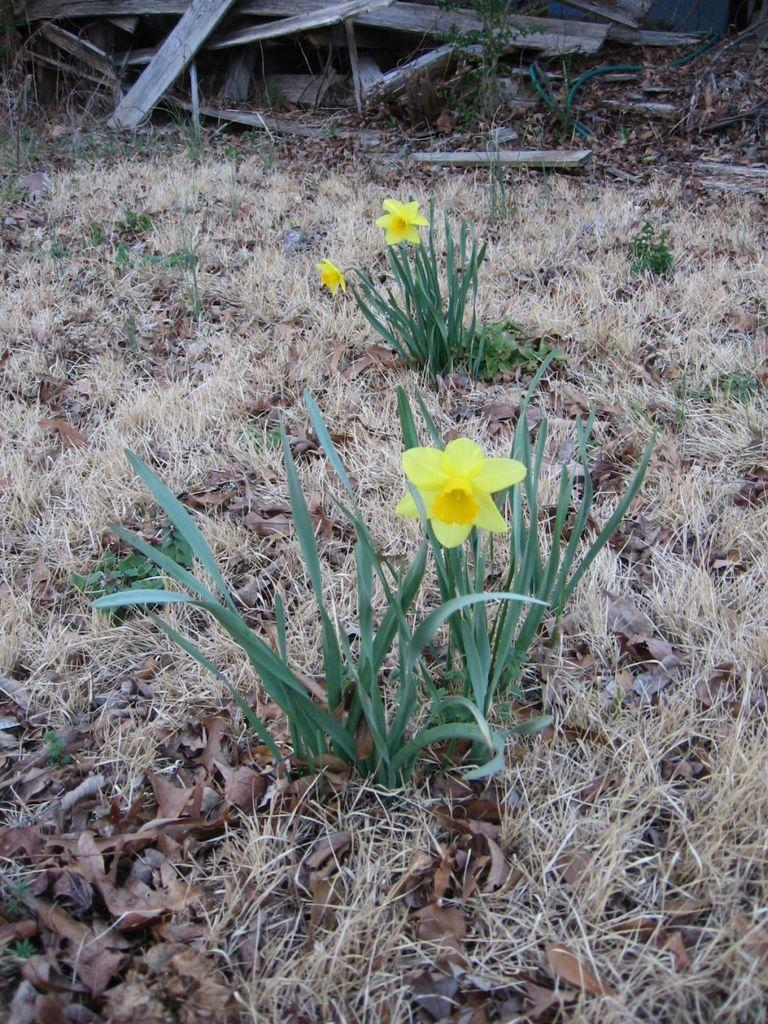What type of vegetation can be seen in the image? There are plants and flowers in the image. What is present on the ground in the image? There are dry leaves and grass on the ground. What can be seen in the background of the image? There are wooden objects in the background of the image. What type of toothbrush is being used to clean the fang in the image? There is no toothbrush or fang present in the image. What meal is being prepared in the image? There is no meal preparation visible in the image. 